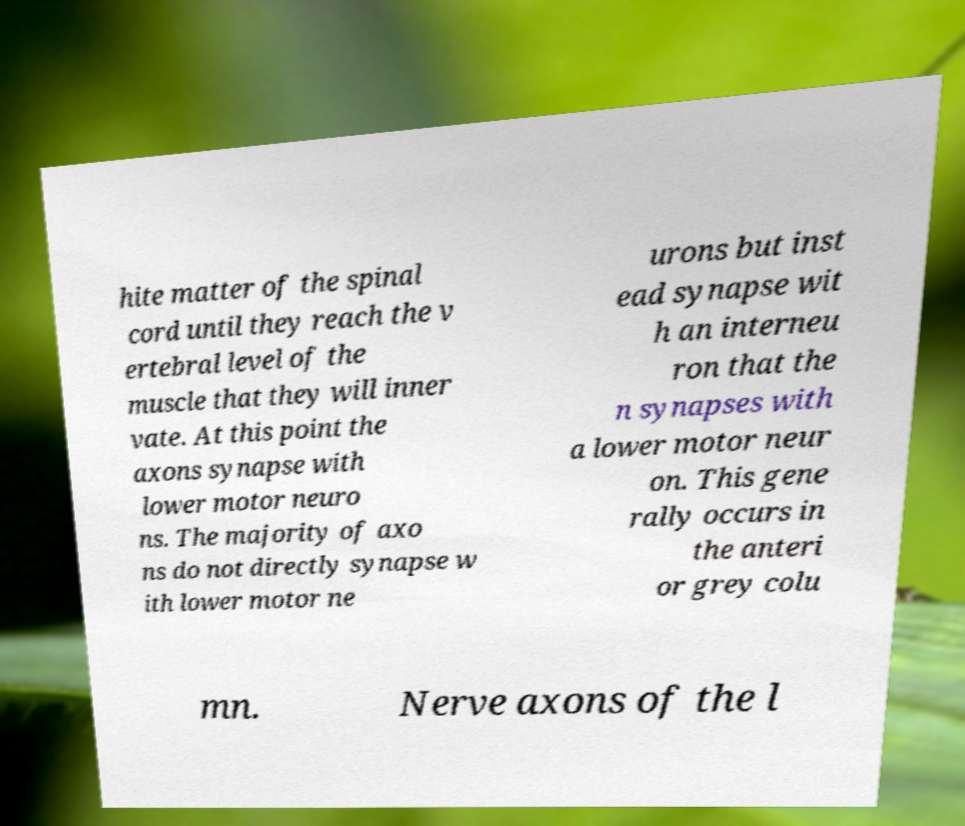Could you extract and type out the text from this image? hite matter of the spinal cord until they reach the v ertebral level of the muscle that they will inner vate. At this point the axons synapse with lower motor neuro ns. The majority of axo ns do not directly synapse w ith lower motor ne urons but inst ead synapse wit h an interneu ron that the n synapses with a lower motor neur on. This gene rally occurs in the anteri or grey colu mn. Nerve axons of the l 